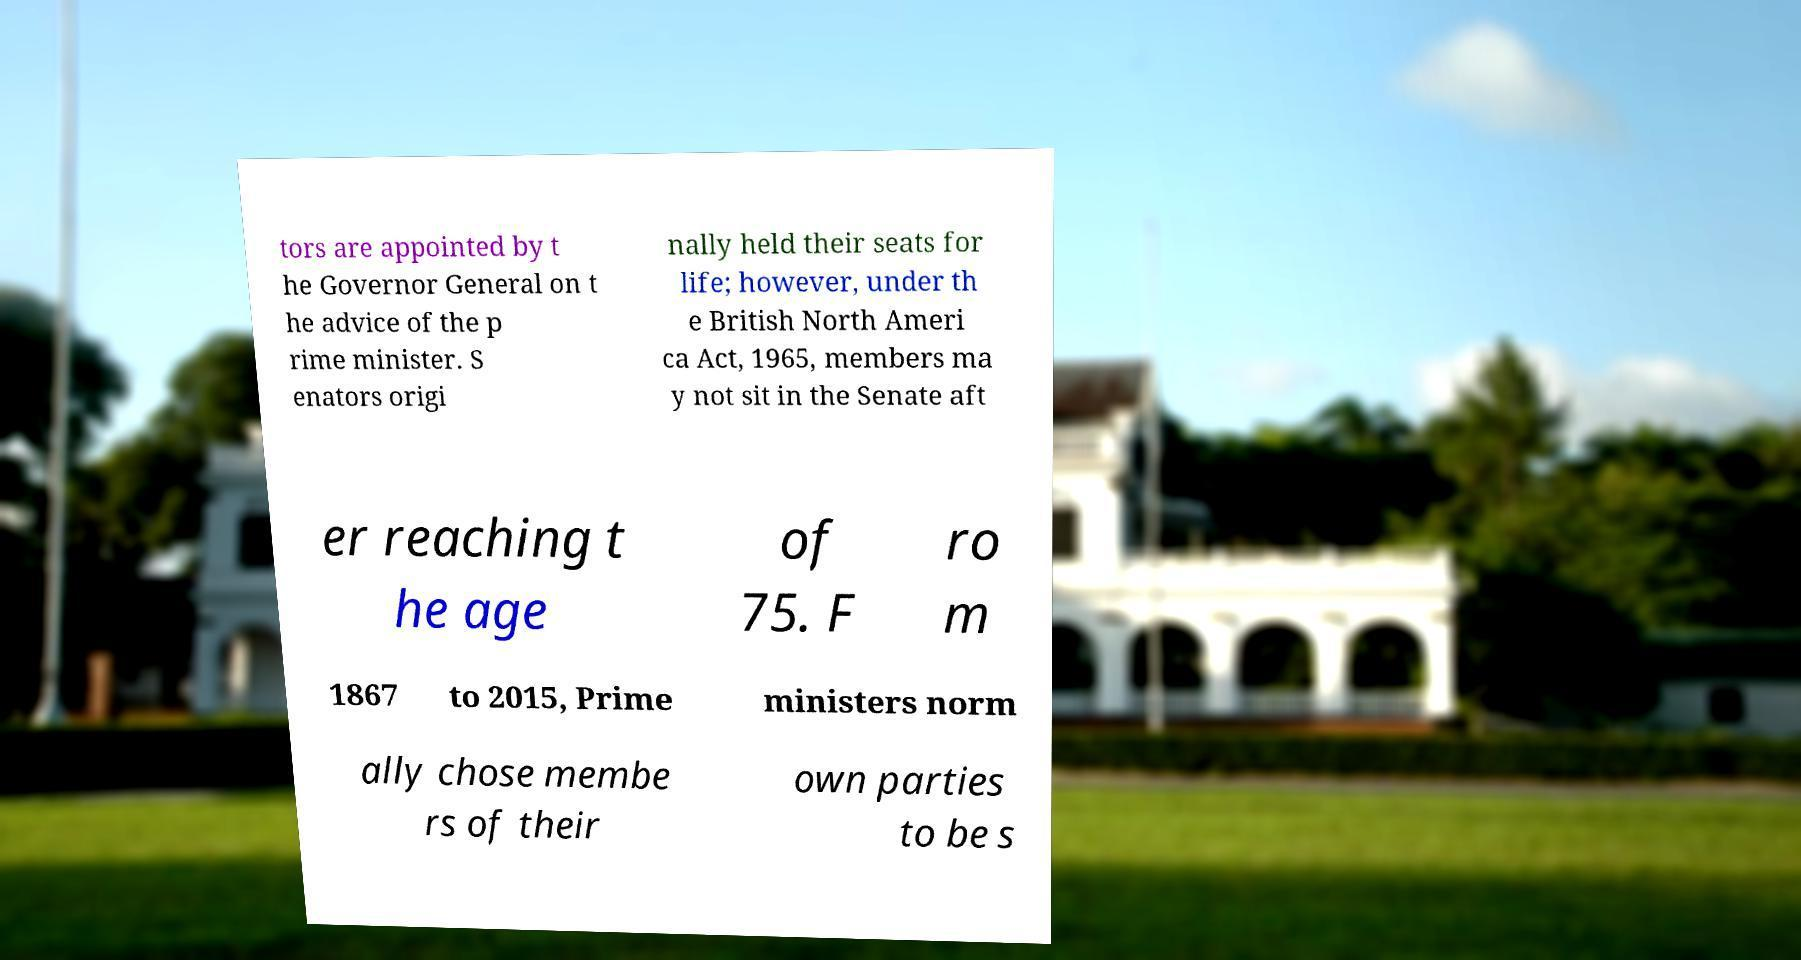Can you read and provide the text displayed in the image?This photo seems to have some interesting text. Can you extract and type it out for me? tors are appointed by t he Governor General on t he advice of the p rime minister. S enators origi nally held their seats for life; however, under th e British North Ameri ca Act, 1965, members ma y not sit in the Senate aft er reaching t he age of 75. F ro m 1867 to 2015, Prime ministers norm ally chose membe rs of their own parties to be s 